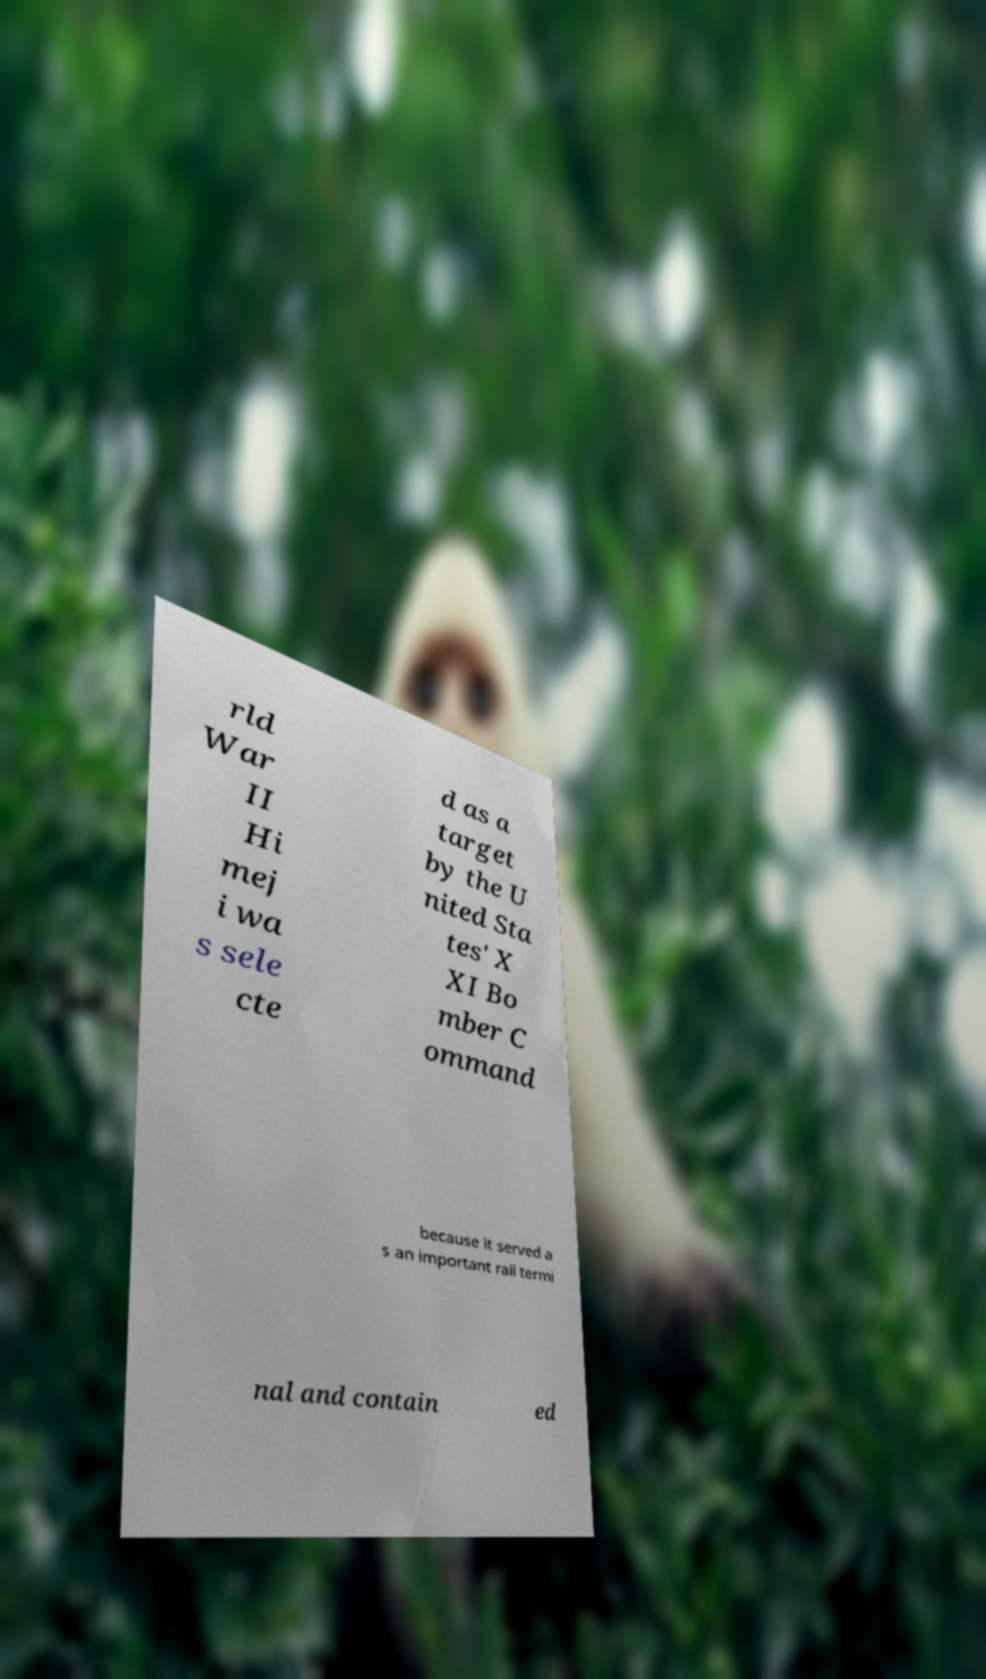Can you read and provide the text displayed in the image?This photo seems to have some interesting text. Can you extract and type it out for me? rld War II Hi mej i wa s sele cte d as a target by the U nited Sta tes' X XI Bo mber C ommand because it served a s an important rail termi nal and contain ed 